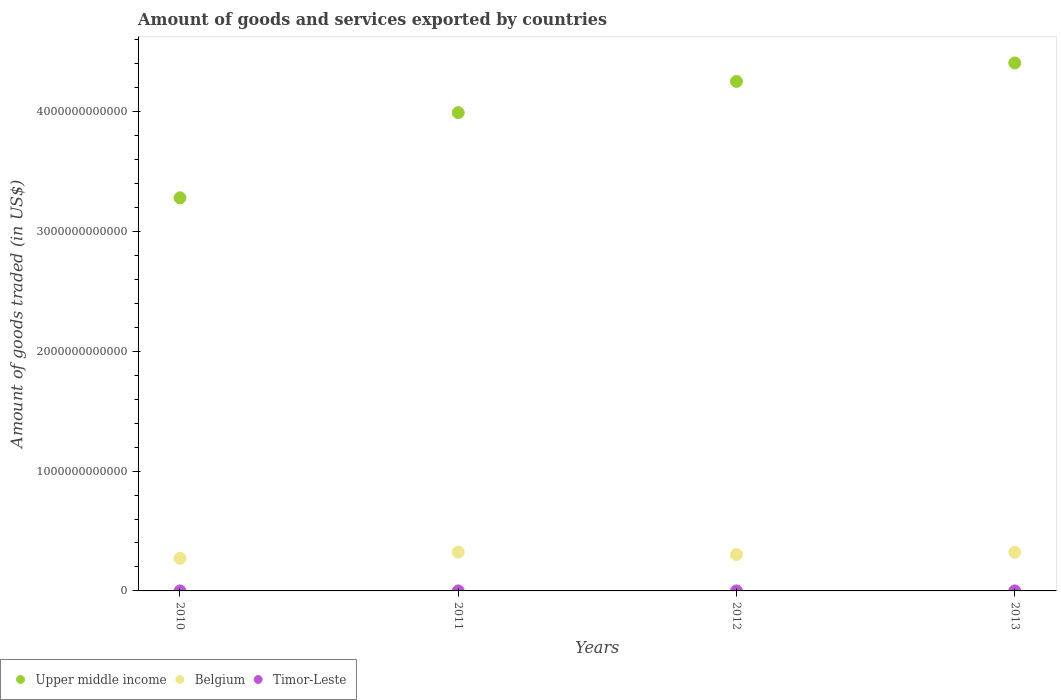How many different coloured dotlines are there?
Offer a very short reply. 3. Is the number of dotlines equal to the number of legend labels?
Offer a terse response. Yes. What is the total amount of goods and services exported in Belgium in 2011?
Provide a short and direct response. 3.24e+11. Across all years, what is the maximum total amount of goods and services exported in Timor-Leste?
Make the answer very short. 3.33e+07. Across all years, what is the minimum total amount of goods and services exported in Upper middle income?
Keep it short and to the point. 3.28e+12. In which year was the total amount of goods and services exported in Timor-Leste minimum?
Make the answer very short. 2013. What is the total total amount of goods and services exported in Upper middle income in the graph?
Your response must be concise. 1.59e+13. What is the difference between the total amount of goods and services exported in Timor-Leste in 2011 and that in 2013?
Provide a succinct answer. 1.10e+07. What is the difference between the total amount of goods and services exported in Belgium in 2012 and the total amount of goods and services exported in Upper middle income in 2010?
Offer a terse response. -2.98e+12. What is the average total amount of goods and services exported in Upper middle income per year?
Offer a terse response. 3.98e+12. In the year 2011, what is the difference between the total amount of goods and services exported in Timor-Leste and total amount of goods and services exported in Belgium?
Your response must be concise. -3.24e+11. In how many years, is the total amount of goods and services exported in Upper middle income greater than 1400000000000 US$?
Offer a very short reply. 4. What is the ratio of the total amount of goods and services exported in Timor-Leste in 2010 to that in 2012?
Your response must be concise. 0.81. Is the total amount of goods and services exported in Timor-Leste in 2010 less than that in 2013?
Your response must be concise. No. What is the difference between the highest and the second highest total amount of goods and services exported in Timor-Leste?
Give a very brief answer. 4.59e+06. What is the difference between the highest and the lowest total amount of goods and services exported in Belgium?
Provide a short and direct response. 5.22e+1. In how many years, is the total amount of goods and services exported in Upper middle income greater than the average total amount of goods and services exported in Upper middle income taken over all years?
Your response must be concise. 3. Is the sum of the total amount of goods and services exported in Timor-Leste in 2011 and 2012 greater than the maximum total amount of goods and services exported in Belgium across all years?
Make the answer very short. No. Is it the case that in every year, the sum of the total amount of goods and services exported in Timor-Leste and total amount of goods and services exported in Upper middle income  is greater than the total amount of goods and services exported in Belgium?
Your answer should be compact. Yes. Is the total amount of goods and services exported in Timor-Leste strictly less than the total amount of goods and services exported in Belgium over the years?
Give a very brief answer. Yes. How many years are there in the graph?
Provide a succinct answer. 4. What is the difference between two consecutive major ticks on the Y-axis?
Provide a short and direct response. 1.00e+12. Are the values on the major ticks of Y-axis written in scientific E-notation?
Your answer should be very brief. No. Does the graph contain any zero values?
Keep it short and to the point. No. Where does the legend appear in the graph?
Provide a succinct answer. Bottom left. How many legend labels are there?
Ensure brevity in your answer.  3. How are the legend labels stacked?
Your answer should be very brief. Horizontal. What is the title of the graph?
Provide a succinct answer. Amount of goods and services exported by countries. What is the label or title of the X-axis?
Offer a terse response. Years. What is the label or title of the Y-axis?
Give a very brief answer. Amount of goods traded (in US$). What is the Amount of goods traded (in US$) of Upper middle income in 2010?
Keep it short and to the point. 3.28e+12. What is the Amount of goods traded (in US$) of Belgium in 2010?
Offer a very short reply. 2.71e+11. What is the Amount of goods traded (in US$) in Timor-Leste in 2010?
Ensure brevity in your answer.  2.71e+07. What is the Amount of goods traded (in US$) of Upper middle income in 2011?
Give a very brief answer. 3.99e+12. What is the Amount of goods traded (in US$) in Belgium in 2011?
Your answer should be compact. 3.24e+11. What is the Amount of goods traded (in US$) in Timor-Leste in 2011?
Provide a short and direct response. 2.87e+07. What is the Amount of goods traded (in US$) in Upper middle income in 2012?
Keep it short and to the point. 4.25e+12. What is the Amount of goods traded (in US$) in Belgium in 2012?
Provide a short and direct response. 3.04e+11. What is the Amount of goods traded (in US$) of Timor-Leste in 2012?
Offer a terse response. 3.33e+07. What is the Amount of goods traded (in US$) in Upper middle income in 2013?
Provide a succinct answer. 4.41e+12. What is the Amount of goods traded (in US$) in Belgium in 2013?
Offer a terse response. 3.22e+11. What is the Amount of goods traded (in US$) in Timor-Leste in 2013?
Provide a short and direct response. 1.77e+07. Across all years, what is the maximum Amount of goods traded (in US$) in Upper middle income?
Offer a terse response. 4.41e+12. Across all years, what is the maximum Amount of goods traded (in US$) in Belgium?
Your response must be concise. 3.24e+11. Across all years, what is the maximum Amount of goods traded (in US$) of Timor-Leste?
Give a very brief answer. 3.33e+07. Across all years, what is the minimum Amount of goods traded (in US$) of Upper middle income?
Provide a short and direct response. 3.28e+12. Across all years, what is the minimum Amount of goods traded (in US$) of Belgium?
Ensure brevity in your answer.  2.71e+11. Across all years, what is the minimum Amount of goods traded (in US$) of Timor-Leste?
Keep it short and to the point. 1.77e+07. What is the total Amount of goods traded (in US$) in Upper middle income in the graph?
Give a very brief answer. 1.59e+13. What is the total Amount of goods traded (in US$) in Belgium in the graph?
Offer a terse response. 1.22e+12. What is the total Amount of goods traded (in US$) in Timor-Leste in the graph?
Provide a succinct answer. 1.07e+08. What is the difference between the Amount of goods traded (in US$) of Upper middle income in 2010 and that in 2011?
Make the answer very short. -7.11e+11. What is the difference between the Amount of goods traded (in US$) in Belgium in 2010 and that in 2011?
Your response must be concise. -5.22e+1. What is the difference between the Amount of goods traded (in US$) of Timor-Leste in 2010 and that in 2011?
Offer a terse response. -1.60e+06. What is the difference between the Amount of goods traded (in US$) of Upper middle income in 2010 and that in 2012?
Keep it short and to the point. -9.71e+11. What is the difference between the Amount of goods traded (in US$) of Belgium in 2010 and that in 2012?
Your response must be concise. -3.22e+1. What is the difference between the Amount of goods traded (in US$) of Timor-Leste in 2010 and that in 2012?
Make the answer very short. -6.19e+06. What is the difference between the Amount of goods traded (in US$) in Upper middle income in 2010 and that in 2013?
Keep it short and to the point. -1.13e+12. What is the difference between the Amount of goods traded (in US$) in Belgium in 2010 and that in 2013?
Your answer should be very brief. -5.05e+1. What is the difference between the Amount of goods traded (in US$) of Timor-Leste in 2010 and that in 2013?
Your response must be concise. 9.41e+06. What is the difference between the Amount of goods traded (in US$) of Upper middle income in 2011 and that in 2012?
Make the answer very short. -2.61e+11. What is the difference between the Amount of goods traded (in US$) of Belgium in 2011 and that in 2012?
Your answer should be compact. 2.01e+1. What is the difference between the Amount of goods traded (in US$) in Timor-Leste in 2011 and that in 2012?
Keep it short and to the point. -4.59e+06. What is the difference between the Amount of goods traded (in US$) in Upper middle income in 2011 and that in 2013?
Keep it short and to the point. -4.15e+11. What is the difference between the Amount of goods traded (in US$) in Belgium in 2011 and that in 2013?
Your answer should be compact. 1.76e+09. What is the difference between the Amount of goods traded (in US$) in Timor-Leste in 2011 and that in 2013?
Offer a very short reply. 1.10e+07. What is the difference between the Amount of goods traded (in US$) of Upper middle income in 2012 and that in 2013?
Provide a succinct answer. -1.54e+11. What is the difference between the Amount of goods traded (in US$) in Belgium in 2012 and that in 2013?
Ensure brevity in your answer.  -1.83e+1. What is the difference between the Amount of goods traded (in US$) in Timor-Leste in 2012 and that in 2013?
Offer a terse response. 1.56e+07. What is the difference between the Amount of goods traded (in US$) of Upper middle income in 2010 and the Amount of goods traded (in US$) of Belgium in 2011?
Your answer should be compact. 2.96e+12. What is the difference between the Amount of goods traded (in US$) of Upper middle income in 2010 and the Amount of goods traded (in US$) of Timor-Leste in 2011?
Provide a succinct answer. 3.28e+12. What is the difference between the Amount of goods traded (in US$) of Belgium in 2010 and the Amount of goods traded (in US$) of Timor-Leste in 2011?
Provide a succinct answer. 2.71e+11. What is the difference between the Amount of goods traded (in US$) of Upper middle income in 2010 and the Amount of goods traded (in US$) of Belgium in 2012?
Provide a short and direct response. 2.98e+12. What is the difference between the Amount of goods traded (in US$) in Upper middle income in 2010 and the Amount of goods traded (in US$) in Timor-Leste in 2012?
Give a very brief answer. 3.28e+12. What is the difference between the Amount of goods traded (in US$) of Belgium in 2010 and the Amount of goods traded (in US$) of Timor-Leste in 2012?
Your answer should be very brief. 2.71e+11. What is the difference between the Amount of goods traded (in US$) in Upper middle income in 2010 and the Amount of goods traded (in US$) in Belgium in 2013?
Provide a short and direct response. 2.96e+12. What is the difference between the Amount of goods traded (in US$) in Upper middle income in 2010 and the Amount of goods traded (in US$) in Timor-Leste in 2013?
Keep it short and to the point. 3.28e+12. What is the difference between the Amount of goods traded (in US$) in Belgium in 2010 and the Amount of goods traded (in US$) in Timor-Leste in 2013?
Offer a terse response. 2.71e+11. What is the difference between the Amount of goods traded (in US$) in Upper middle income in 2011 and the Amount of goods traded (in US$) in Belgium in 2012?
Your response must be concise. 3.69e+12. What is the difference between the Amount of goods traded (in US$) of Upper middle income in 2011 and the Amount of goods traded (in US$) of Timor-Leste in 2012?
Your answer should be compact. 3.99e+12. What is the difference between the Amount of goods traded (in US$) of Belgium in 2011 and the Amount of goods traded (in US$) of Timor-Leste in 2012?
Your answer should be compact. 3.24e+11. What is the difference between the Amount of goods traded (in US$) in Upper middle income in 2011 and the Amount of goods traded (in US$) in Belgium in 2013?
Keep it short and to the point. 3.67e+12. What is the difference between the Amount of goods traded (in US$) in Upper middle income in 2011 and the Amount of goods traded (in US$) in Timor-Leste in 2013?
Offer a terse response. 3.99e+12. What is the difference between the Amount of goods traded (in US$) of Belgium in 2011 and the Amount of goods traded (in US$) of Timor-Leste in 2013?
Your answer should be very brief. 3.24e+11. What is the difference between the Amount of goods traded (in US$) in Upper middle income in 2012 and the Amount of goods traded (in US$) in Belgium in 2013?
Give a very brief answer. 3.93e+12. What is the difference between the Amount of goods traded (in US$) of Upper middle income in 2012 and the Amount of goods traded (in US$) of Timor-Leste in 2013?
Provide a short and direct response. 4.25e+12. What is the difference between the Amount of goods traded (in US$) in Belgium in 2012 and the Amount of goods traded (in US$) in Timor-Leste in 2013?
Provide a succinct answer. 3.04e+11. What is the average Amount of goods traded (in US$) in Upper middle income per year?
Keep it short and to the point. 3.98e+12. What is the average Amount of goods traded (in US$) of Belgium per year?
Your response must be concise. 3.05e+11. What is the average Amount of goods traded (in US$) in Timor-Leste per year?
Offer a terse response. 2.67e+07. In the year 2010, what is the difference between the Amount of goods traded (in US$) in Upper middle income and Amount of goods traded (in US$) in Belgium?
Keep it short and to the point. 3.01e+12. In the year 2010, what is the difference between the Amount of goods traded (in US$) in Upper middle income and Amount of goods traded (in US$) in Timor-Leste?
Ensure brevity in your answer.  3.28e+12. In the year 2010, what is the difference between the Amount of goods traded (in US$) in Belgium and Amount of goods traded (in US$) in Timor-Leste?
Your response must be concise. 2.71e+11. In the year 2011, what is the difference between the Amount of goods traded (in US$) of Upper middle income and Amount of goods traded (in US$) of Belgium?
Your answer should be very brief. 3.67e+12. In the year 2011, what is the difference between the Amount of goods traded (in US$) of Upper middle income and Amount of goods traded (in US$) of Timor-Leste?
Provide a succinct answer. 3.99e+12. In the year 2011, what is the difference between the Amount of goods traded (in US$) in Belgium and Amount of goods traded (in US$) in Timor-Leste?
Your answer should be compact. 3.24e+11. In the year 2012, what is the difference between the Amount of goods traded (in US$) in Upper middle income and Amount of goods traded (in US$) in Belgium?
Provide a short and direct response. 3.95e+12. In the year 2012, what is the difference between the Amount of goods traded (in US$) in Upper middle income and Amount of goods traded (in US$) in Timor-Leste?
Offer a terse response. 4.25e+12. In the year 2012, what is the difference between the Amount of goods traded (in US$) of Belgium and Amount of goods traded (in US$) of Timor-Leste?
Give a very brief answer. 3.04e+11. In the year 2013, what is the difference between the Amount of goods traded (in US$) of Upper middle income and Amount of goods traded (in US$) of Belgium?
Provide a succinct answer. 4.08e+12. In the year 2013, what is the difference between the Amount of goods traded (in US$) of Upper middle income and Amount of goods traded (in US$) of Timor-Leste?
Your response must be concise. 4.41e+12. In the year 2013, what is the difference between the Amount of goods traded (in US$) of Belgium and Amount of goods traded (in US$) of Timor-Leste?
Keep it short and to the point. 3.22e+11. What is the ratio of the Amount of goods traded (in US$) of Upper middle income in 2010 to that in 2011?
Your answer should be compact. 0.82. What is the ratio of the Amount of goods traded (in US$) of Belgium in 2010 to that in 2011?
Your answer should be compact. 0.84. What is the ratio of the Amount of goods traded (in US$) in Timor-Leste in 2010 to that in 2011?
Give a very brief answer. 0.94. What is the ratio of the Amount of goods traded (in US$) in Upper middle income in 2010 to that in 2012?
Make the answer very short. 0.77. What is the ratio of the Amount of goods traded (in US$) of Belgium in 2010 to that in 2012?
Provide a short and direct response. 0.89. What is the ratio of the Amount of goods traded (in US$) in Timor-Leste in 2010 to that in 2012?
Make the answer very short. 0.81. What is the ratio of the Amount of goods traded (in US$) of Upper middle income in 2010 to that in 2013?
Make the answer very short. 0.74. What is the ratio of the Amount of goods traded (in US$) in Belgium in 2010 to that in 2013?
Keep it short and to the point. 0.84. What is the ratio of the Amount of goods traded (in US$) of Timor-Leste in 2010 to that in 2013?
Your answer should be very brief. 1.53. What is the ratio of the Amount of goods traded (in US$) of Upper middle income in 2011 to that in 2012?
Offer a very short reply. 0.94. What is the ratio of the Amount of goods traded (in US$) in Belgium in 2011 to that in 2012?
Keep it short and to the point. 1.07. What is the ratio of the Amount of goods traded (in US$) of Timor-Leste in 2011 to that in 2012?
Your response must be concise. 0.86. What is the ratio of the Amount of goods traded (in US$) of Upper middle income in 2011 to that in 2013?
Ensure brevity in your answer.  0.91. What is the ratio of the Amount of goods traded (in US$) in Timor-Leste in 2011 to that in 2013?
Give a very brief answer. 1.62. What is the ratio of the Amount of goods traded (in US$) in Upper middle income in 2012 to that in 2013?
Your answer should be very brief. 0.96. What is the ratio of the Amount of goods traded (in US$) in Belgium in 2012 to that in 2013?
Your answer should be very brief. 0.94. What is the ratio of the Amount of goods traded (in US$) of Timor-Leste in 2012 to that in 2013?
Keep it short and to the point. 1.88. What is the difference between the highest and the second highest Amount of goods traded (in US$) of Upper middle income?
Offer a very short reply. 1.54e+11. What is the difference between the highest and the second highest Amount of goods traded (in US$) in Belgium?
Your answer should be very brief. 1.76e+09. What is the difference between the highest and the second highest Amount of goods traded (in US$) in Timor-Leste?
Provide a short and direct response. 4.59e+06. What is the difference between the highest and the lowest Amount of goods traded (in US$) in Upper middle income?
Provide a short and direct response. 1.13e+12. What is the difference between the highest and the lowest Amount of goods traded (in US$) in Belgium?
Keep it short and to the point. 5.22e+1. What is the difference between the highest and the lowest Amount of goods traded (in US$) of Timor-Leste?
Your answer should be very brief. 1.56e+07. 